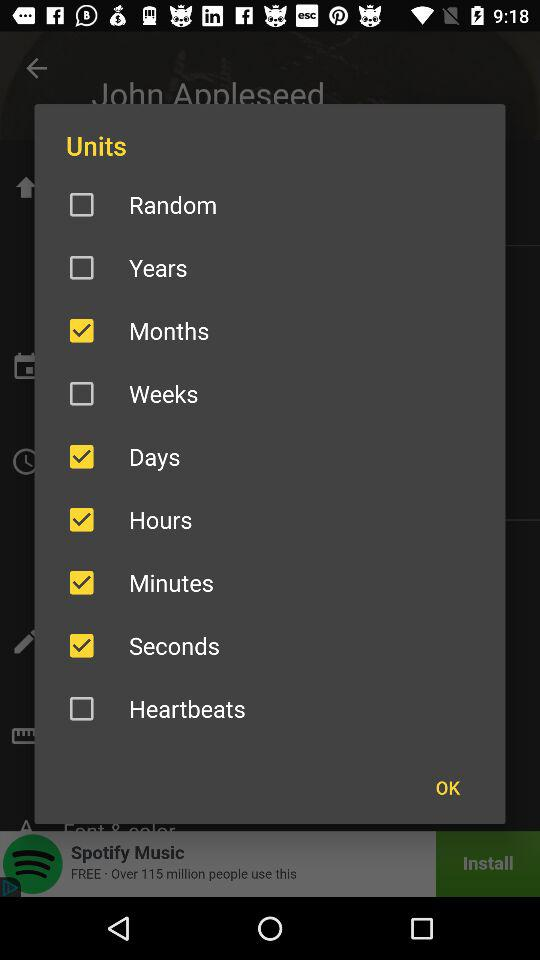What is the status of "Days"? The status is "on". 